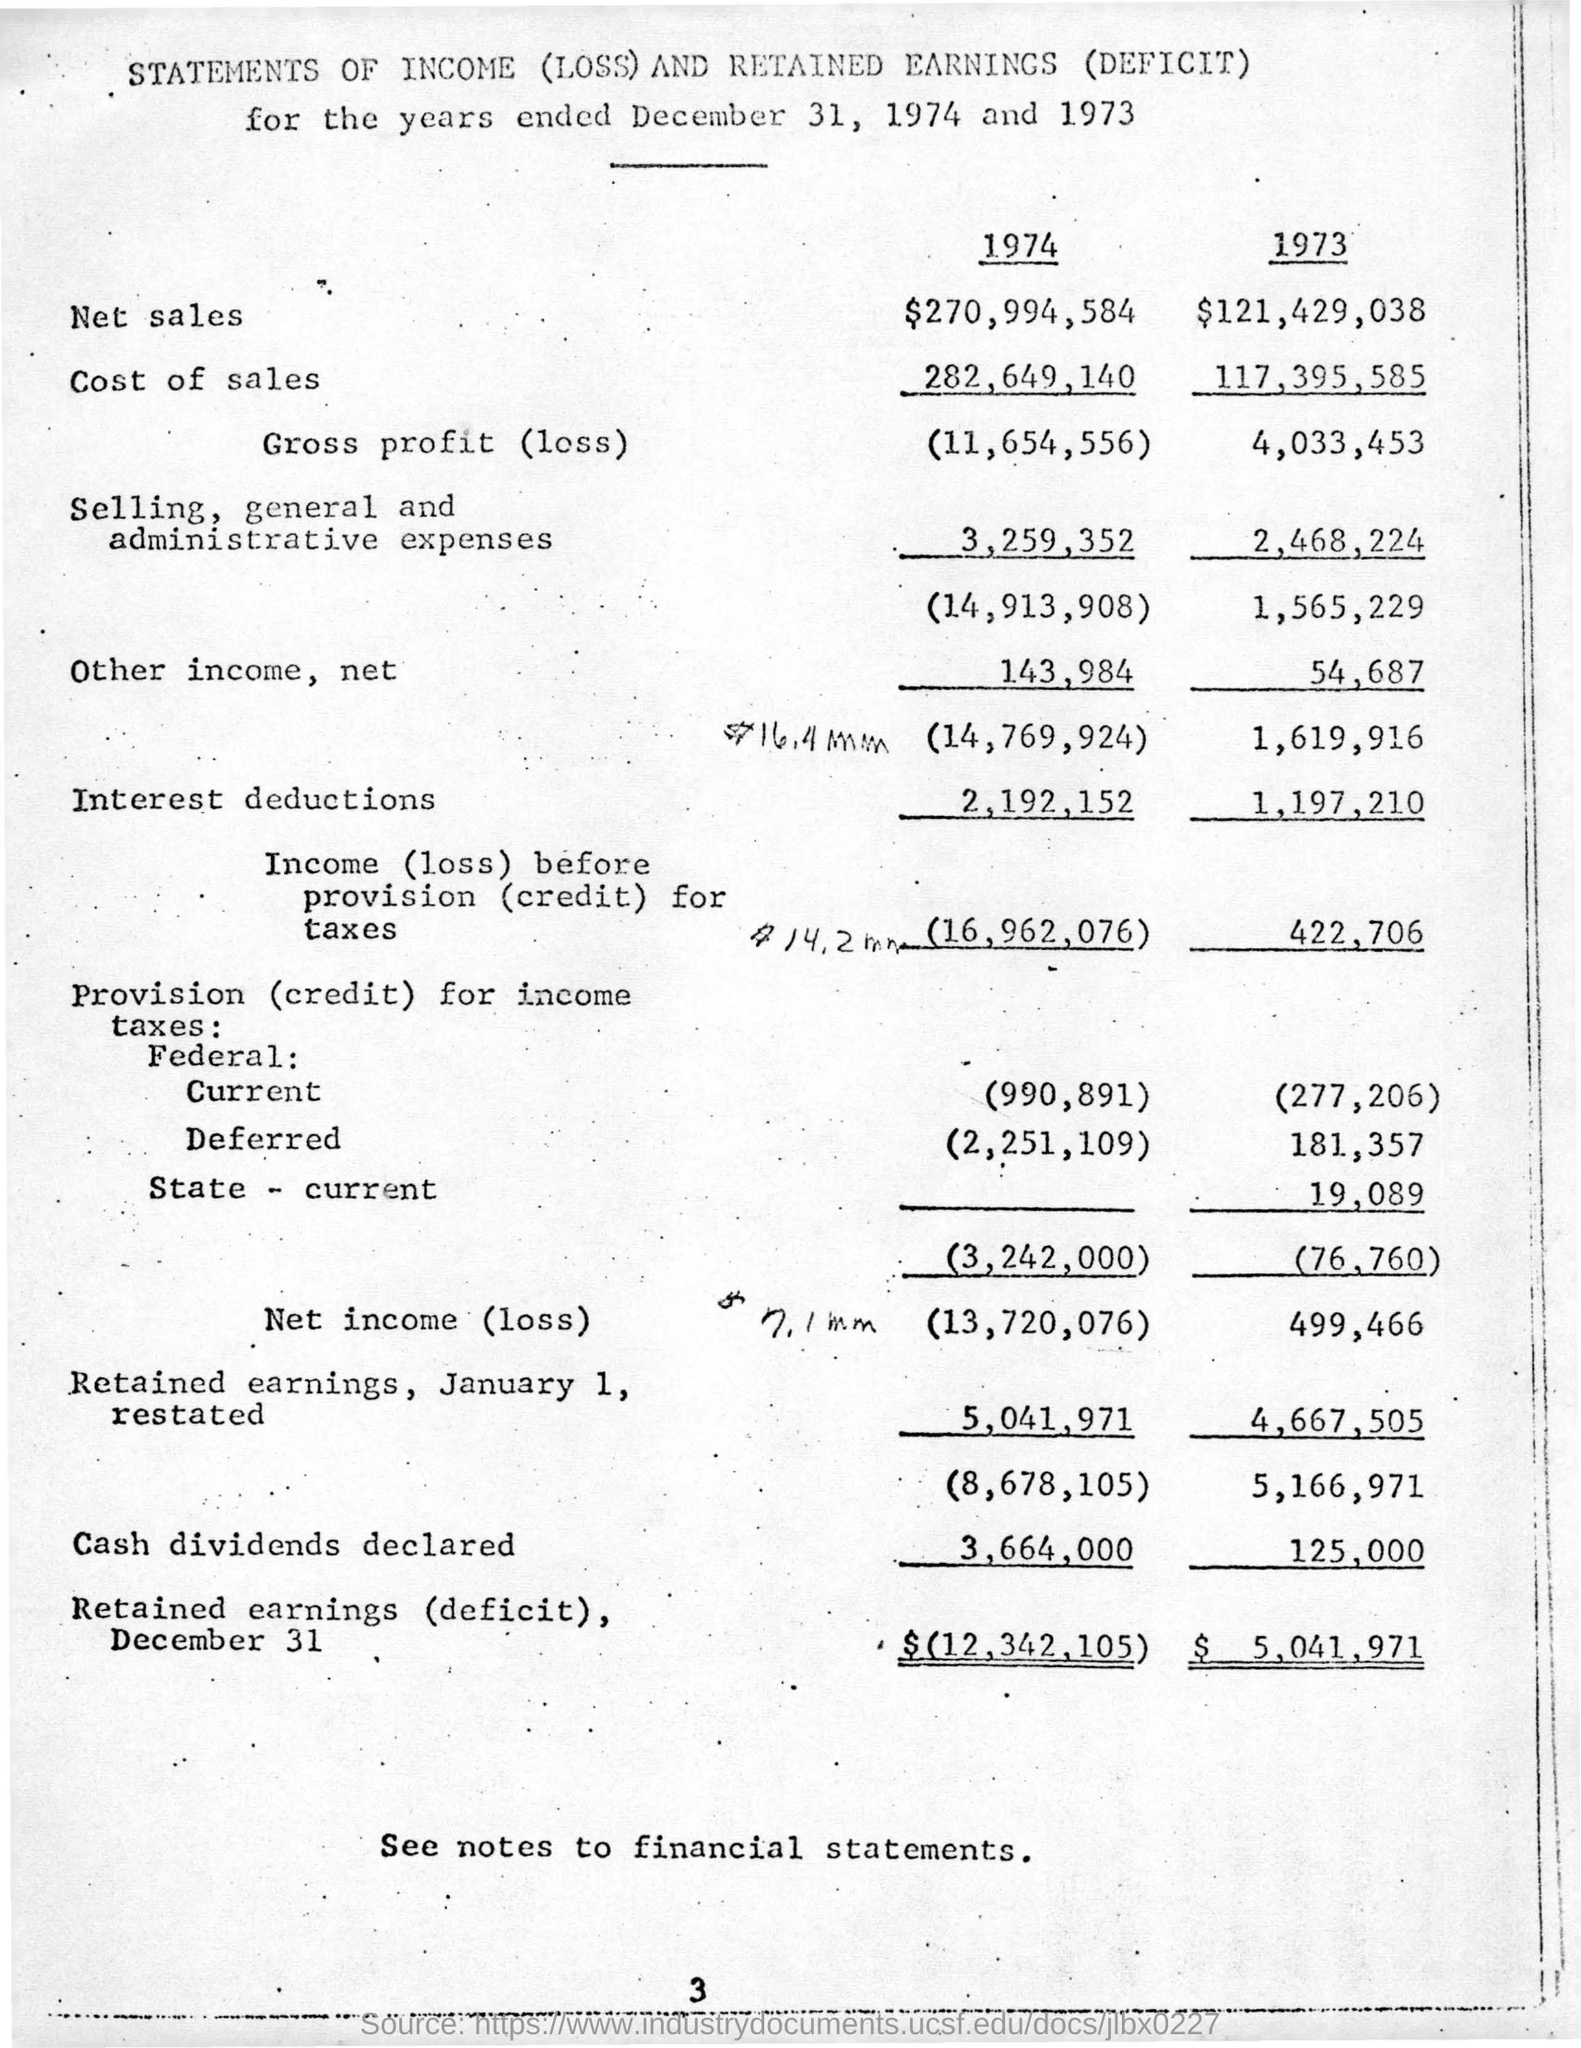What is the amount of net sales in 1974 ?
Provide a succinct answer. $270,994,584. What is the amount of cost of sales in the year 1973?
Your response must be concise. $ 117,395,585. What is the gross profit (loss) for the year 1974 ?
Offer a terse response. 11,654,556. What is the amount of retained earnings (deficit),december 31 for the year 1974?
Ensure brevity in your answer.  $ 12,342,105. What is the amount of selling,general and administrative expenses in the year 1973 ?
Offer a terse response. $ 2,468,224. What is the amount of net income (loss) in the year  1973 ?
Your answer should be very brief. 499,466. 